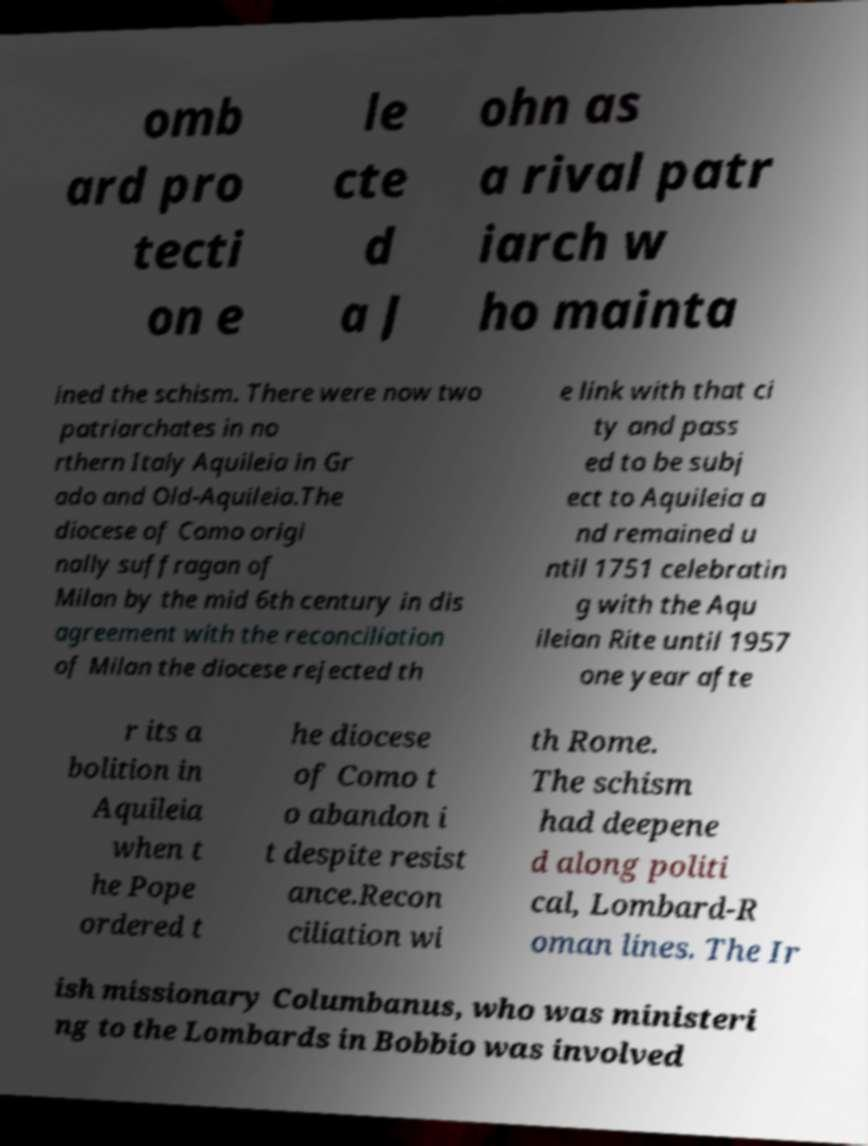Could you extract and type out the text from this image? omb ard pro tecti on e le cte d a J ohn as a rival patr iarch w ho mainta ined the schism. There were now two patriarchates in no rthern Italy Aquileia in Gr ado and Old-Aquileia.The diocese of Como origi nally suffragan of Milan by the mid 6th century in dis agreement with the reconciliation of Milan the diocese rejected th e link with that ci ty and pass ed to be subj ect to Aquileia a nd remained u ntil 1751 celebratin g with the Aqu ileian Rite until 1957 one year afte r its a bolition in Aquileia when t he Pope ordered t he diocese of Como t o abandon i t despite resist ance.Recon ciliation wi th Rome. The schism had deepene d along politi cal, Lombard-R oman lines. The Ir ish missionary Columbanus, who was ministeri ng to the Lombards in Bobbio was involved 